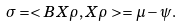<formula> <loc_0><loc_0><loc_500><loc_500>\sigma = < B X \rho , X \rho > = \mu - \psi .</formula> 